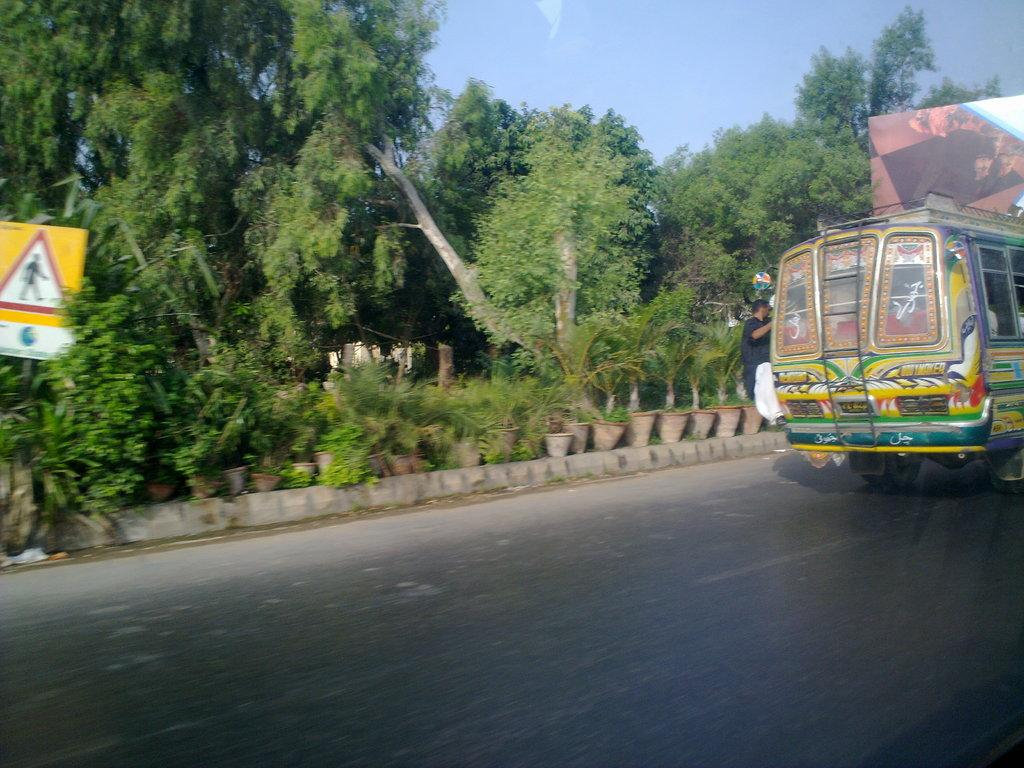What is parked on the road in the image? There is a bus parked on the road in the image. What is the person in the image doing? A person is hanging onto the bus. What type of vegetation can be seen in the image? There are trees visible in the image. What type of plants are kept in the image? There are plants kept in pots in the image. What type of act is the person performing on the bus in the image? There is no act being performed by the person hanging onto the bus in the image. What shape does the wave take in the image? There is no wave present in the image. 